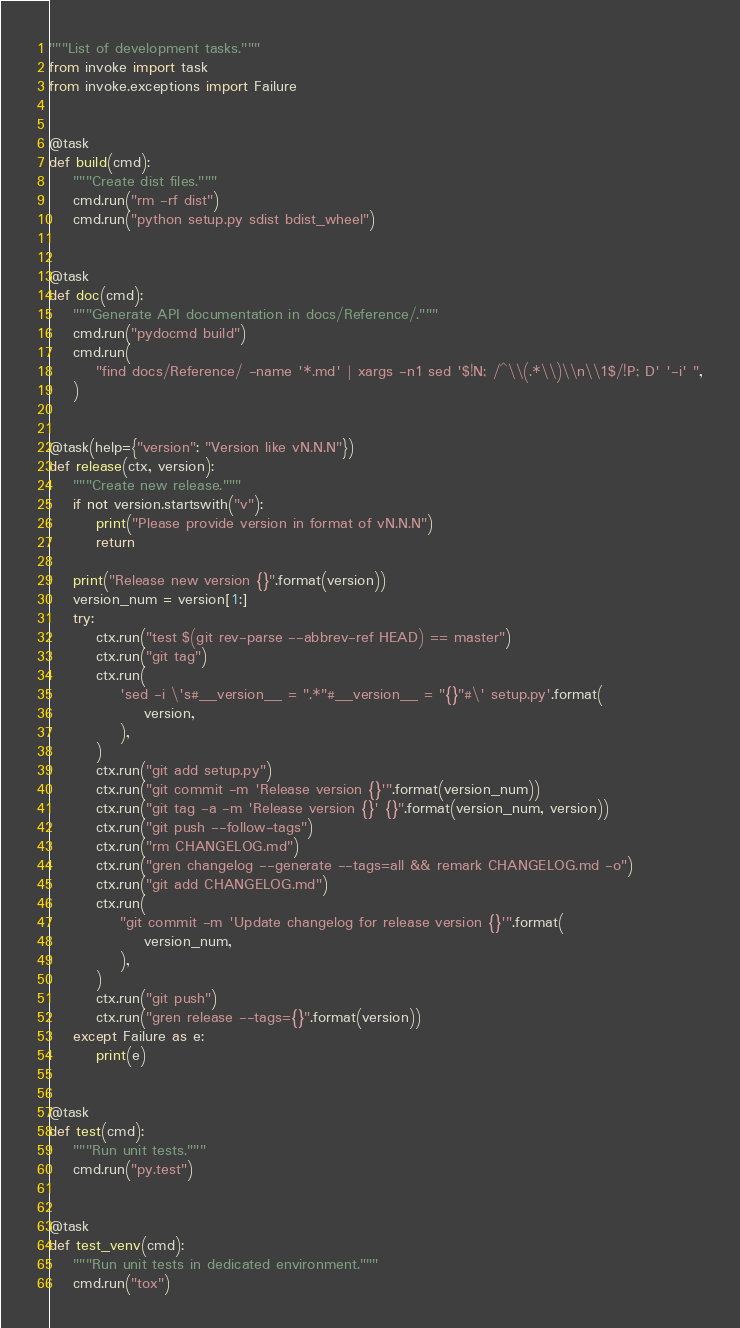Convert code to text. <code><loc_0><loc_0><loc_500><loc_500><_Python_>"""List of development tasks."""
from invoke import task
from invoke.exceptions import Failure


@task
def build(cmd):
    """Create dist files."""
    cmd.run("rm -rf dist")
    cmd.run("python setup.py sdist bdist_wheel")


@task
def doc(cmd):
    """Generate API documentation in docs/Reference/."""
    cmd.run("pydocmd build")
    cmd.run(
        "find docs/Reference/ -name '*.md' | xargs -n1 sed '$!N; /^\\(.*\\)\\n\\1$/!P; D' '-i' ",
    )


@task(help={"version": "Version like vN.N.N"})
def release(ctx, version):
    """Create new release."""
    if not version.startswith("v"):
        print("Please provide version in format of vN.N.N")
        return

    print("Release new version {}".format(version))
    version_num = version[1:]
    try:
        ctx.run("test $(git rev-parse --abbrev-ref HEAD) == master")
        ctx.run("git tag")
        ctx.run(
            'sed -i \'s#__version__ = ".*"#__version__ = "{}"#\' setup.py'.format(
                version,
            ),
        )
        ctx.run("git add setup.py")
        ctx.run("git commit -m 'Release version {}'".format(version_num))
        ctx.run("git tag -a -m 'Release version {}' {}".format(version_num, version))
        ctx.run("git push --follow-tags")
        ctx.run("rm CHANGELOG.md")
        ctx.run("gren changelog --generate --tags=all && remark CHANGELOG.md -o")
        ctx.run("git add CHANGELOG.md")
        ctx.run(
            "git commit -m 'Update changelog for release version {}'".format(
                version_num,
            ),
        )
        ctx.run("git push")
        ctx.run("gren release --tags={}".format(version))
    except Failure as e:
        print(e)


@task
def test(cmd):
    """Run unit tests."""
    cmd.run("py.test")


@task
def test_venv(cmd):
    """Run unit tests in dedicated environment."""
    cmd.run("tox")
</code> 